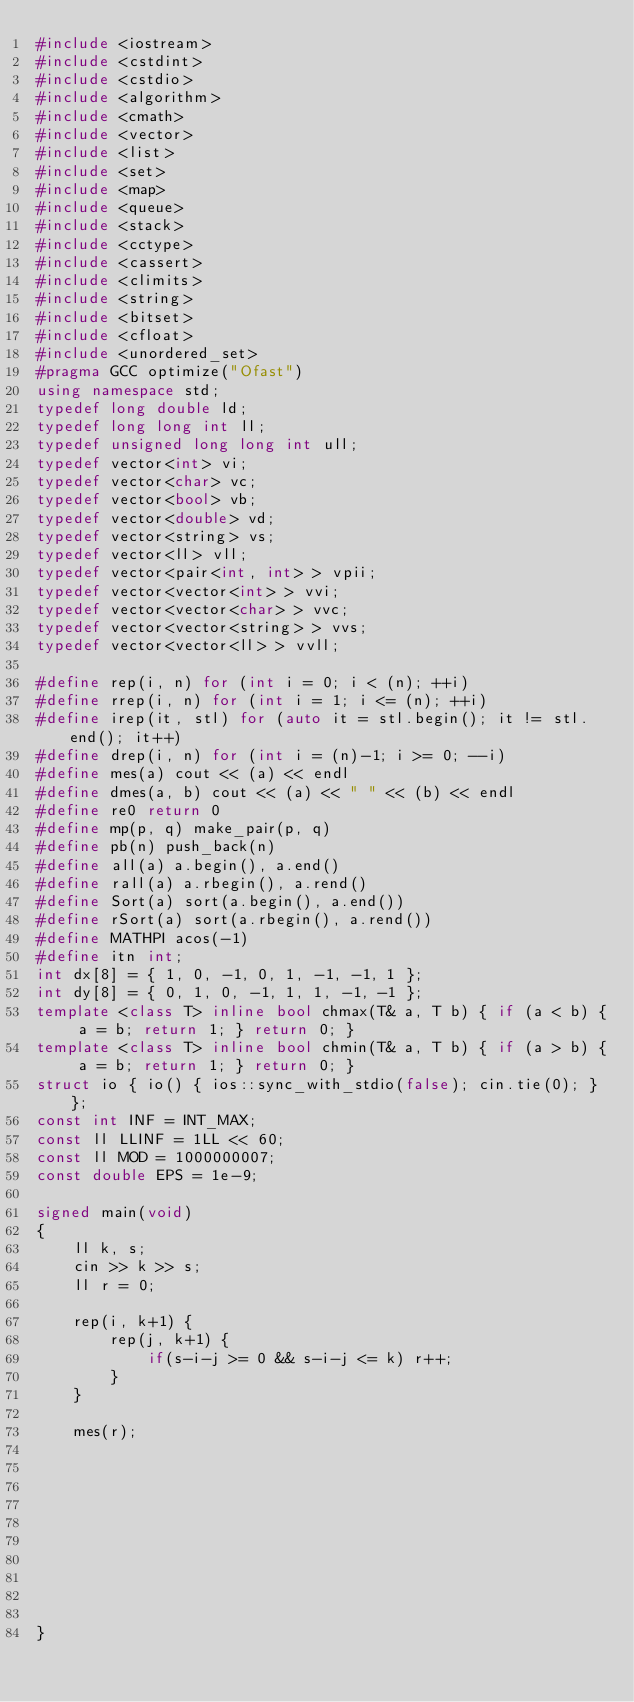Convert code to text. <code><loc_0><loc_0><loc_500><loc_500><_C++_>#include <iostream>
#include <cstdint>
#include <cstdio>
#include <algorithm>
#include <cmath>
#include <vector>
#include <list>
#include <set>
#include <map>
#include <queue>
#include <stack>
#include <cctype>
#include <cassert>
#include <climits>
#include <string>
#include <bitset>
#include <cfloat>
#include <unordered_set>
#pragma GCC optimize("Ofast")
using namespace std;
typedef long double ld;
typedef long long int ll;
typedef unsigned long long int ull;
typedef vector<int> vi;
typedef vector<char> vc;
typedef vector<bool> vb;
typedef vector<double> vd;
typedef vector<string> vs;
typedef vector<ll> vll;
typedef vector<pair<int, int> > vpii;
typedef vector<vector<int> > vvi;
typedef vector<vector<char> > vvc;
typedef vector<vector<string> > vvs;
typedef vector<vector<ll> > vvll;

#define rep(i, n) for (int i = 0; i < (n); ++i)
#define rrep(i, n) for (int i = 1; i <= (n); ++i)
#define irep(it, stl) for (auto it = stl.begin(); it != stl.end(); it++)
#define drep(i, n) for (int i = (n)-1; i >= 0; --i)
#define mes(a) cout << (a) << endl
#define dmes(a, b) cout << (a) << " " << (b) << endl
#define re0 return 0
#define mp(p, q) make_pair(p, q)
#define pb(n) push_back(n)
#define all(a) a.begin(), a.end()
#define rall(a) a.rbegin(), a.rend()
#define Sort(a) sort(a.begin(), a.end())
#define rSort(a) sort(a.rbegin(), a.rend())
#define MATHPI acos(-1)
#define itn int;
int dx[8] = { 1, 0, -1, 0, 1, -1, -1, 1 };
int dy[8] = { 0, 1, 0, -1, 1, 1, -1, -1 };
template <class T> inline bool chmax(T& a, T b) { if (a < b) { a = b; return 1; } return 0; }
template <class T> inline bool chmin(T& a, T b) { if (a > b) { a = b; return 1; } return 0; }
struct io { io() { ios::sync_with_stdio(false); cin.tie(0); } };
const int INF = INT_MAX;
const ll LLINF = 1LL << 60;
const ll MOD = 1000000007;
const double EPS = 1e-9;

signed main(void)
{    
    ll k, s;
    cin >> k >> s;
    ll r = 0;
    
    rep(i, k+1) {
        rep(j, k+1) {
            if(s-i-j >= 0 && s-i-j <= k) r++;
        }
    }
    
    mes(r);
	
    
    
    
    
    
    
    
    
    
}</code> 